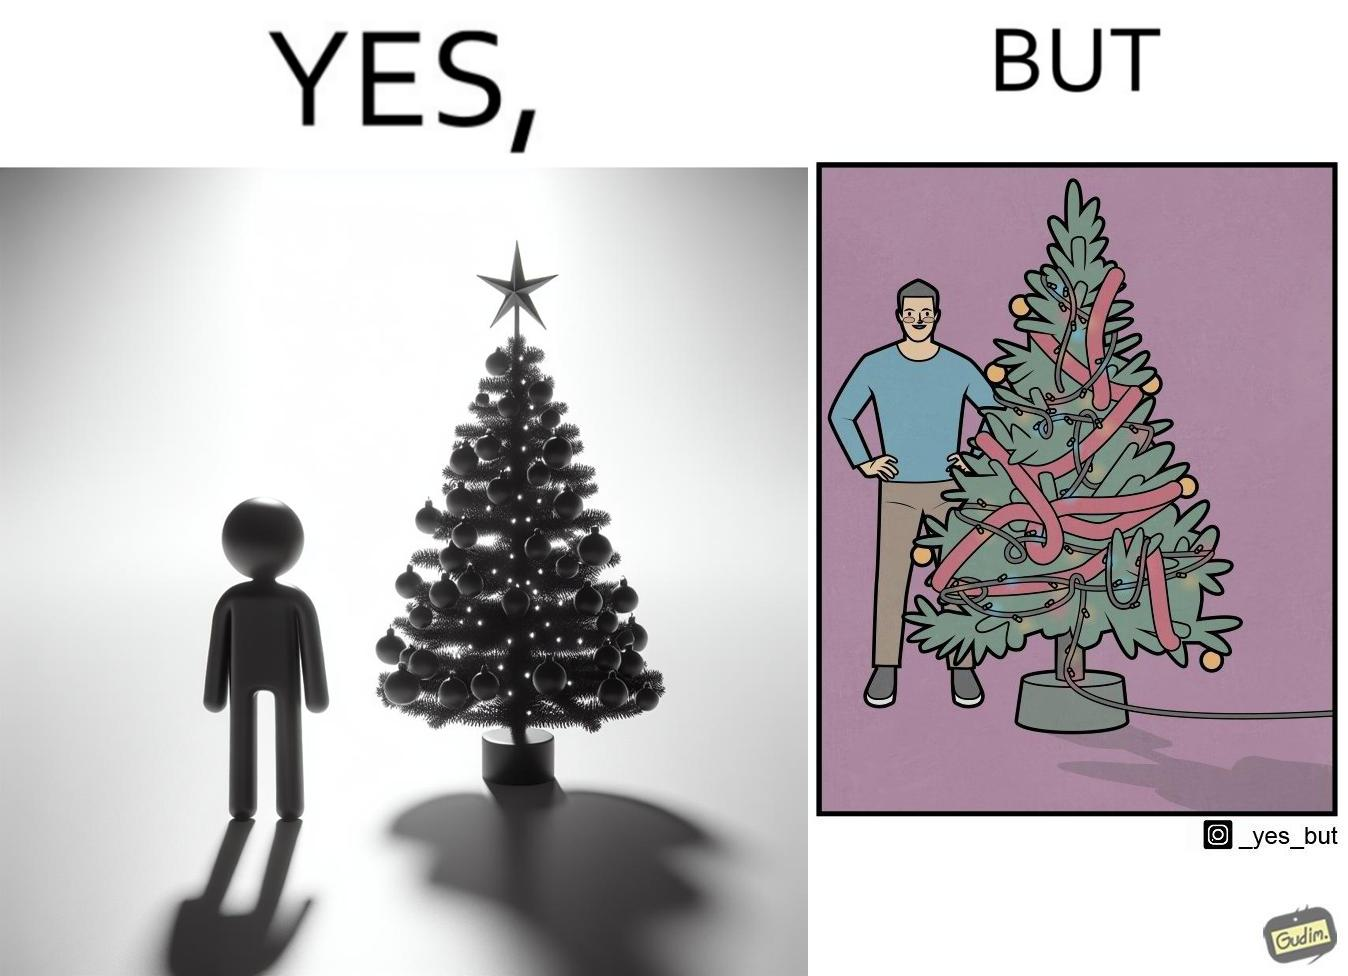Provide a description of this image. The image is ironic, because in the first image a person is seen watching his decorated X-mas tree but in the second image it is shown that the tree is looking beautiful not due to its natural beauty but the bulbs connected via power decorated over it 